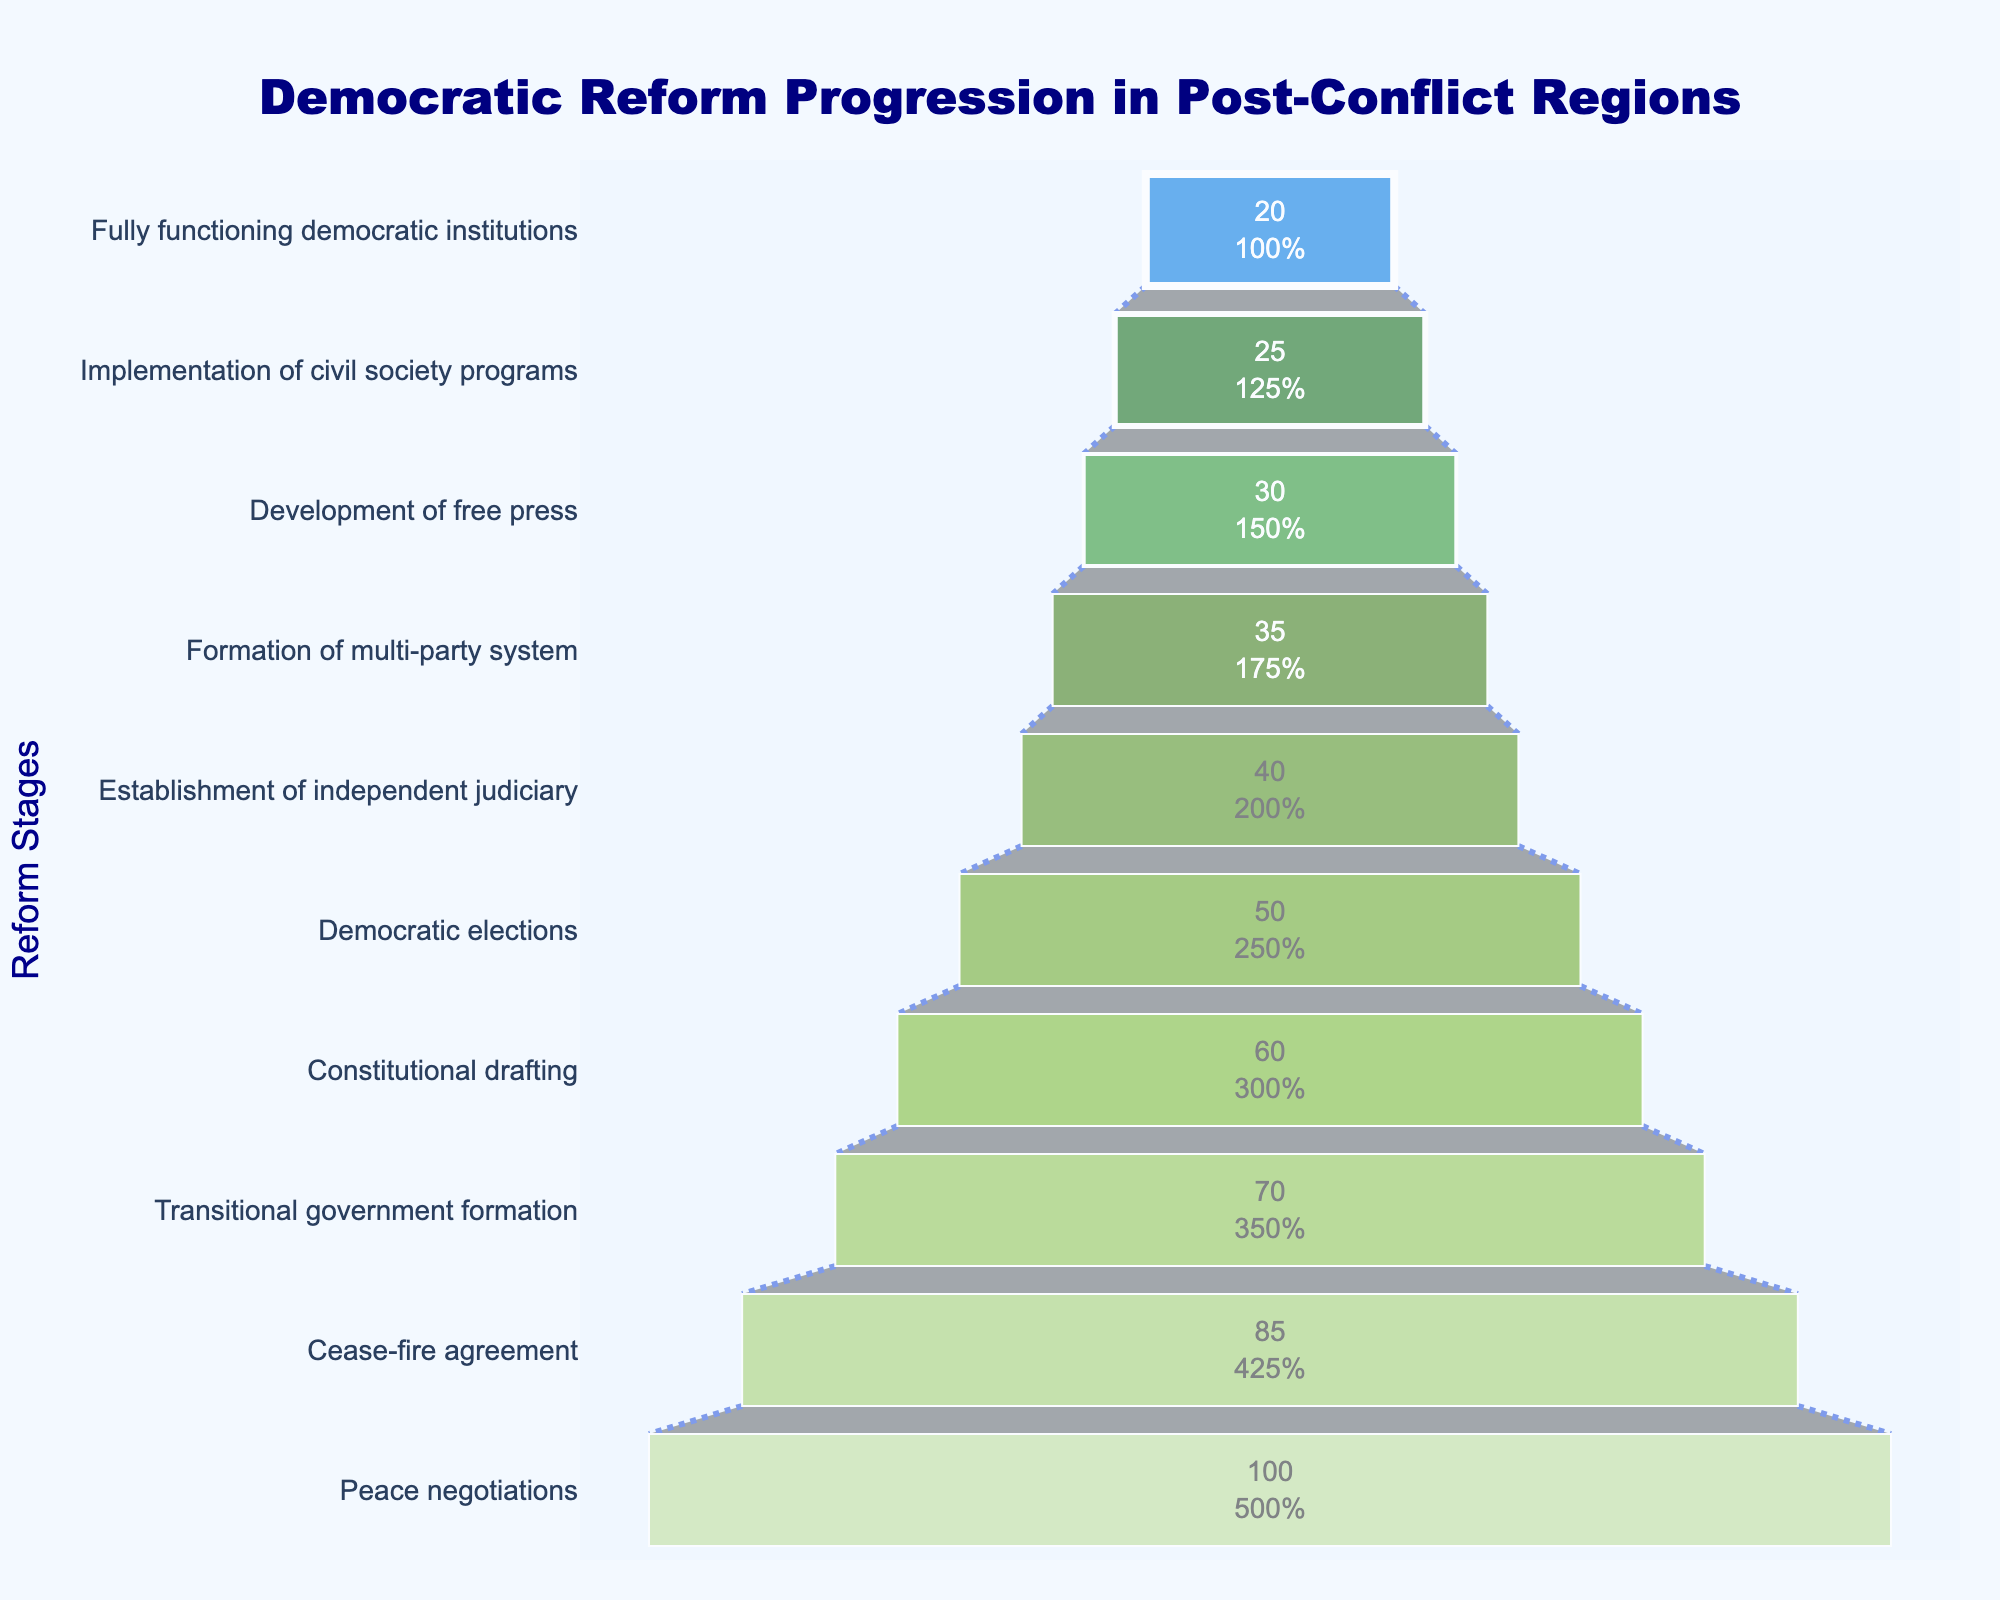What is the title of the funnel chart? The title is located at the top of the funnel chart. It reads: "Democratic Reform Progression in Post-Conflict Regions"
Answer: Democratic Reform Progression in Post-Conflict Regions What is the percentage for 'Cease-fire agreement' stage? Locate the 'Cease-fire agreement' stage on the funnel chart and refer to the percentage value beside it. It reads 85%.
Answer: 85% Which stage shows the initial progression of 100%? The initial progression of 100% is shown at the top of the funnel chart. It corresponds to the 'Peace negotiations' stage.
Answer: Peace negotiations How many stages are there in the funnel chart? Count each stage in the funnel chart from top to bottom. There are 10 stages in total.
Answer: 10 What is the difference in percentage between 'Democratic elections' and 'Development of free press'? Subtract the percentage of 'Development of free press' (30%) from that of 'Democratic elections' (50%). The difference is 20%.
Answer: 20% Which stage shows the lowest progress percentage? The lowest progress percentage is shown at the bottom of the funnel chart, corresponding to the 'Fully functioning democratic institutions' stage, which is 20%.
Answer: Fully functioning democratic institutions How much higher is the percentage for 'Constitutional drafting' compared to 'Formation of multi-party system'? Subtract the percentage of 'Formation of multi-party system' (35%) from that of 'Constitutional drafting' (60%). The difference is 25%.
Answer: 25% What stages have a percentage lower than 50%? Identify and list the stages below the 50% mark on the funnel chart: 'Establishment of independent judiciary' (40%), 'Formation of multi-party system' (35%), 'Development of free press' (30%), 'Implementation of civil society programs' (25%), 'Fully functioning democratic institutions' (20%).
Answer: Establishment of independent judiciary, Formation of multi-party system, Development of free press, Implementation of civil society programs, Fully functioning democratic institutions What is the average percentage of the stages 'Constitutional drafting', 'Democratic elections', and 'Establishment of independent judiciary'? Add the percentages of the three stages: (60% + 50% + 40%) = 150%, then divide by 3. The average is 50%.
Answer: 50% How does the percentage of 'Peace negotiations' compare to the average percentage of 'Cease-fire agreement' and 'Transitional government formation'? Calculate the average percentage of 'Cease-fire agreement' (85%) and 'Transitional government formation' (70%): (85% + 70%) / 2 = 77.5%. Compare this with 'Peace negotiations' (100%). The 'Peace negotiations' percentage is higher.
Answer: Higher 